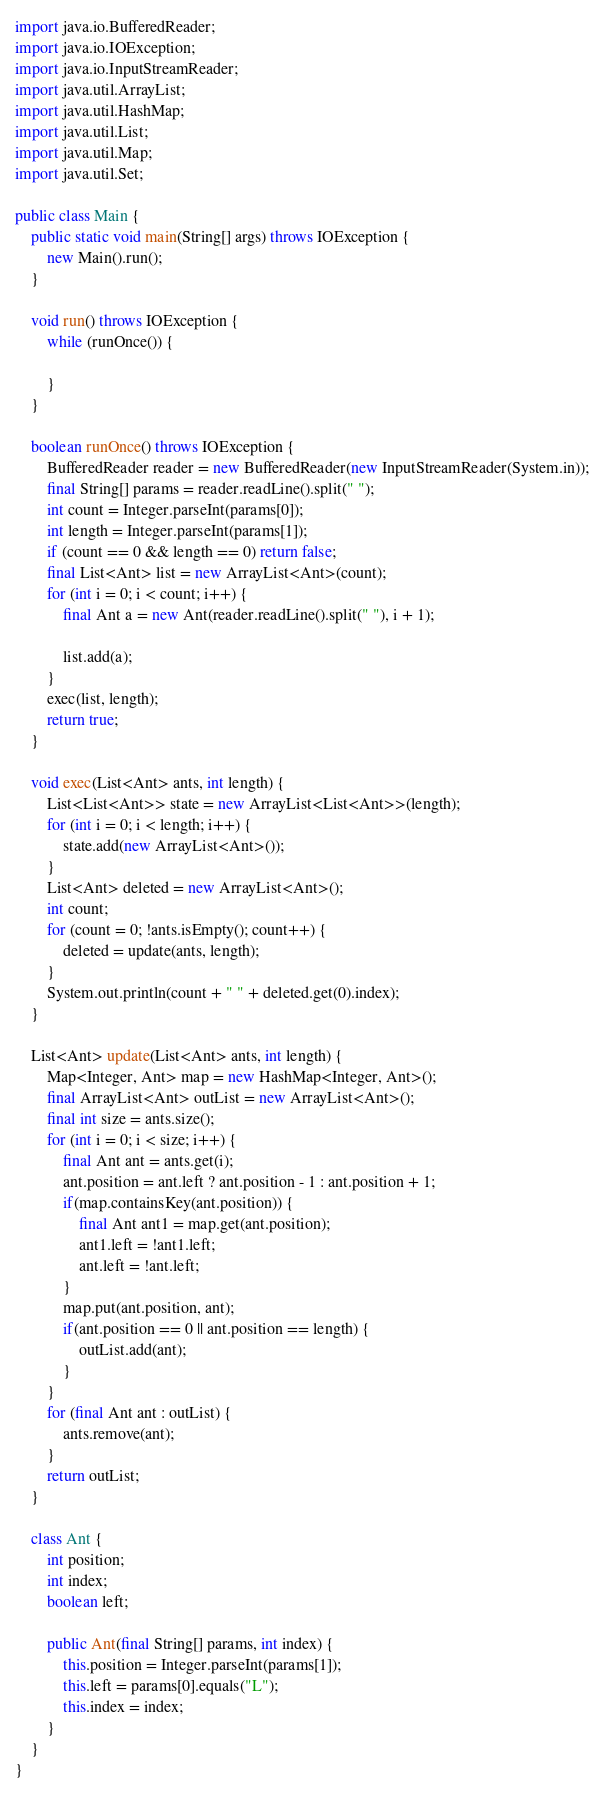<code> <loc_0><loc_0><loc_500><loc_500><_Java_>
import java.io.BufferedReader;
import java.io.IOException;
import java.io.InputStreamReader;
import java.util.ArrayList;
import java.util.HashMap;
import java.util.List;
import java.util.Map;
import java.util.Set;

public class Main {
    public static void main(String[] args) throws IOException {
        new Main().run();
    }

    void run() throws IOException {
        while (runOnce()) {

        }
    }

    boolean runOnce() throws IOException {
        BufferedReader reader = new BufferedReader(new InputStreamReader(System.in));
        final String[] params = reader.readLine().split(" ");
        int count = Integer.parseInt(params[0]);
        int length = Integer.parseInt(params[1]);
        if (count == 0 && length == 0) return false;
        final List<Ant> list = new ArrayList<Ant>(count);
        for (int i = 0; i < count; i++) {
            final Ant a = new Ant(reader.readLine().split(" "), i + 1);

            list.add(a);
        }
        exec(list, length);
        return true;
    }

    void exec(List<Ant> ants, int length) {
        List<List<Ant>> state = new ArrayList<List<Ant>>(length);
        for (int i = 0; i < length; i++) {
            state.add(new ArrayList<Ant>());
        }
        List<Ant> deleted = new ArrayList<Ant>();
        int count;
        for (count = 0; !ants.isEmpty(); count++) {
            deleted = update(ants, length);
        }
        System.out.println(count + " " + deleted.get(0).index);
    }

    List<Ant> update(List<Ant> ants, int length) {
        Map<Integer, Ant> map = new HashMap<Integer, Ant>();
        final ArrayList<Ant> outList = new ArrayList<Ant>();
        final int size = ants.size();
        for (int i = 0; i < size; i++) {
            final Ant ant = ants.get(i);
            ant.position = ant.left ? ant.position - 1 : ant.position + 1;
            if(map.containsKey(ant.position)) {
                final Ant ant1 = map.get(ant.position);
                ant1.left = !ant1.left;
                ant.left = !ant.left;
            }
            map.put(ant.position, ant);
            if(ant.position == 0 || ant.position == length) {
                outList.add(ant);
            }
        }
        for (final Ant ant : outList) {
            ants.remove(ant);
        }
        return outList;
    }

    class Ant {
        int position;
        int index;
        boolean left;

        public Ant(final String[] params, int index) {
            this.position = Integer.parseInt(params[1]);
            this.left = params[0].equals("L");
            this.index = index;
        }
    }
}</code> 